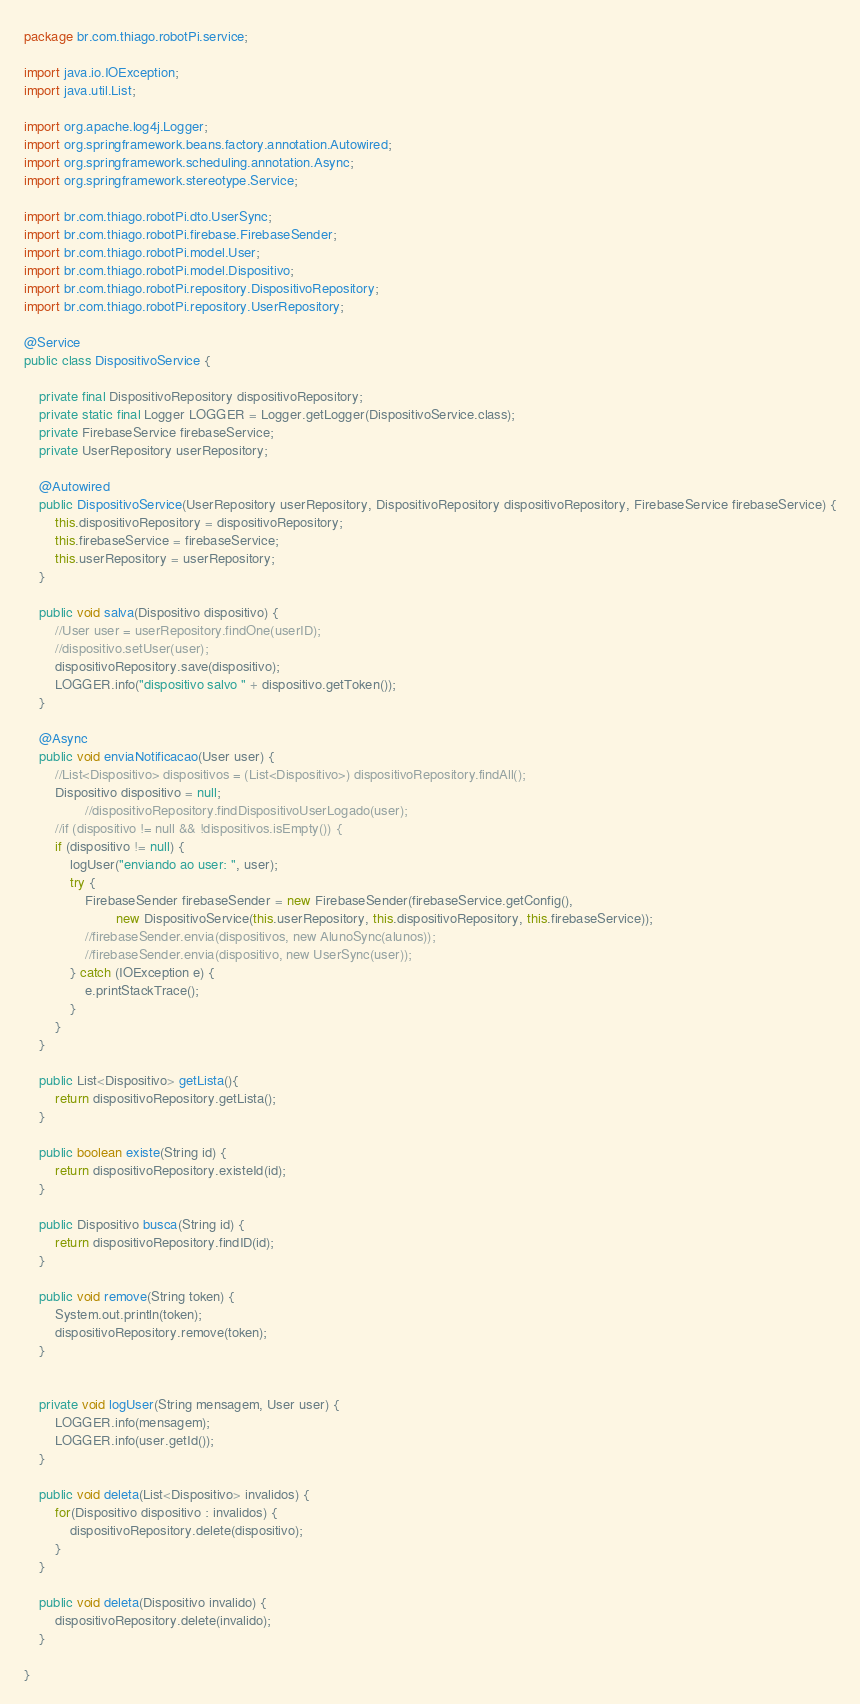Convert code to text. <code><loc_0><loc_0><loc_500><loc_500><_Java_>package br.com.thiago.robotPi.service;

import java.io.IOException;
import java.util.List;

import org.apache.log4j.Logger;
import org.springframework.beans.factory.annotation.Autowired;
import org.springframework.scheduling.annotation.Async;
import org.springframework.stereotype.Service;

import br.com.thiago.robotPi.dto.UserSync;
import br.com.thiago.robotPi.firebase.FirebaseSender;
import br.com.thiago.robotPi.model.User;
import br.com.thiago.robotPi.model.Dispositivo;
import br.com.thiago.robotPi.repository.DispositivoRepository;
import br.com.thiago.robotPi.repository.UserRepository;

@Service
public class DispositivoService {

	private final DispositivoRepository dispositivoRepository;
	private static final Logger LOGGER = Logger.getLogger(DispositivoService.class);
	private FirebaseService firebaseService;
	private UserRepository userRepository;

	@Autowired
	public DispositivoService(UserRepository userRepository, DispositivoRepository dispositivoRepository, FirebaseService firebaseService) {
		this.dispositivoRepository = dispositivoRepository;
		this.firebaseService = firebaseService;
		this.userRepository = userRepository;
	}

	public void salva(Dispositivo dispositivo) {
		//User user = userRepository.findOne(userID);
		//dispositivo.setUser(user);
		dispositivoRepository.save(dispositivo);
		LOGGER.info("dispositivo salvo " + dispositivo.getToken());		
	}

	@Async
	public void enviaNotificacao(User user) {
		//List<Dispositivo> dispositivos = (List<Dispositivo>) dispositivoRepository.findAll();
		Dispositivo dispositivo = null;
				//dispositivoRepository.findDispositivoUserLogado(user);
		//if (dispositivo != null && !dispositivos.isEmpty()) {
		if (dispositivo != null) {
			logUser("enviando ao user: ", user);
			try {
				FirebaseSender firebaseSender = new FirebaseSender(firebaseService.getConfig(),
						new DispositivoService(this.userRepository, this.dispositivoRepository, this.firebaseService));
				//firebaseSender.envia(dispositivos, new AlunoSync(alunos));
				//firebaseSender.envia(dispositivo, new UserSync(user));
			} catch (IOException e) {
				e.printStackTrace();
			}
		}
	}
	
	public List<Dispositivo> getLista(){
		return dispositivoRepository.getLista();
	}
		
	public boolean existe(String id) {
		return dispositivoRepository.existeId(id);
	}
	
	public Dispositivo busca(String id) {
		return dispositivoRepository.findID(id);
	}

	public void remove(String token) {
		System.out.println(token);
		dispositivoRepository.remove(token);
	}
	

	private void logUser(String mensagem, User user) {
		LOGGER.info(mensagem);
		LOGGER.info(user.getId());
	}

	public void deleta(List<Dispositivo> invalidos) {
		for(Dispositivo dispositivo : invalidos) {
			dispositivoRepository.delete(dispositivo);
		}	
	}
	
	public void deleta(Dispositivo invalido) {
		dispositivoRepository.delete(invalido);	
	}

}
</code> 